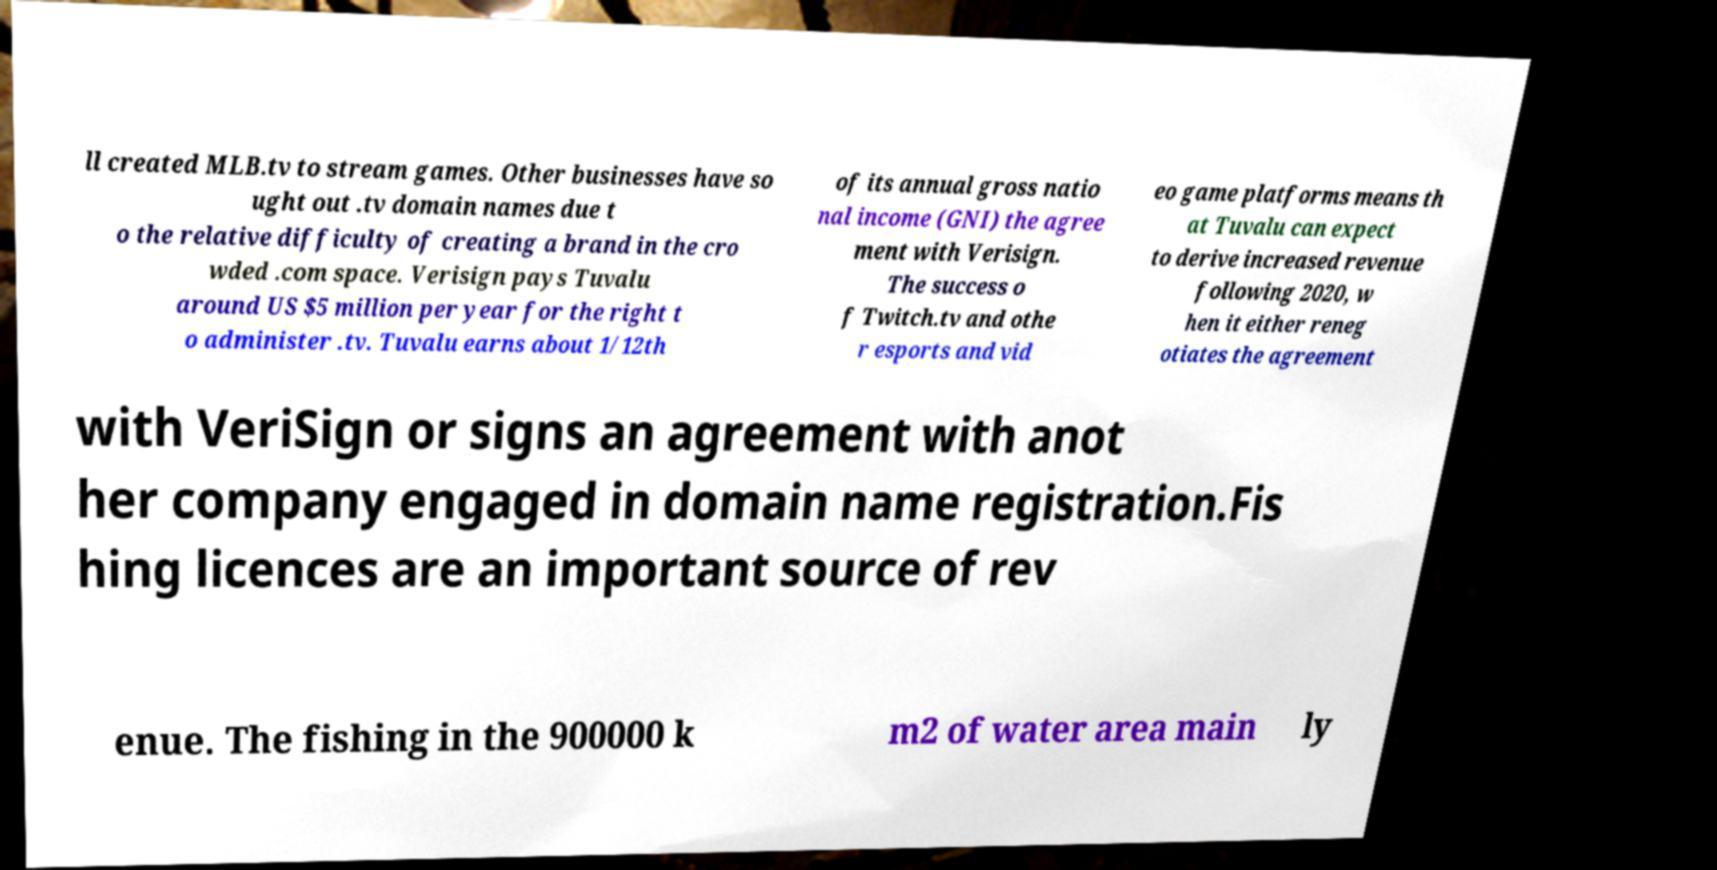There's text embedded in this image that I need extracted. Can you transcribe it verbatim? ll created MLB.tv to stream games. Other businesses have so ught out .tv domain names due t o the relative difficulty of creating a brand in the cro wded .com space. Verisign pays Tuvalu around US $5 million per year for the right t o administer .tv. Tuvalu earns about 1/12th of its annual gross natio nal income (GNI) the agree ment with Verisign. The success o f Twitch.tv and othe r esports and vid eo game platforms means th at Tuvalu can expect to derive increased revenue following 2020, w hen it either reneg otiates the agreement with VeriSign or signs an agreement with anot her company engaged in domain name registration.Fis hing licences are an important source of rev enue. The fishing in the 900000 k m2 of water area main ly 